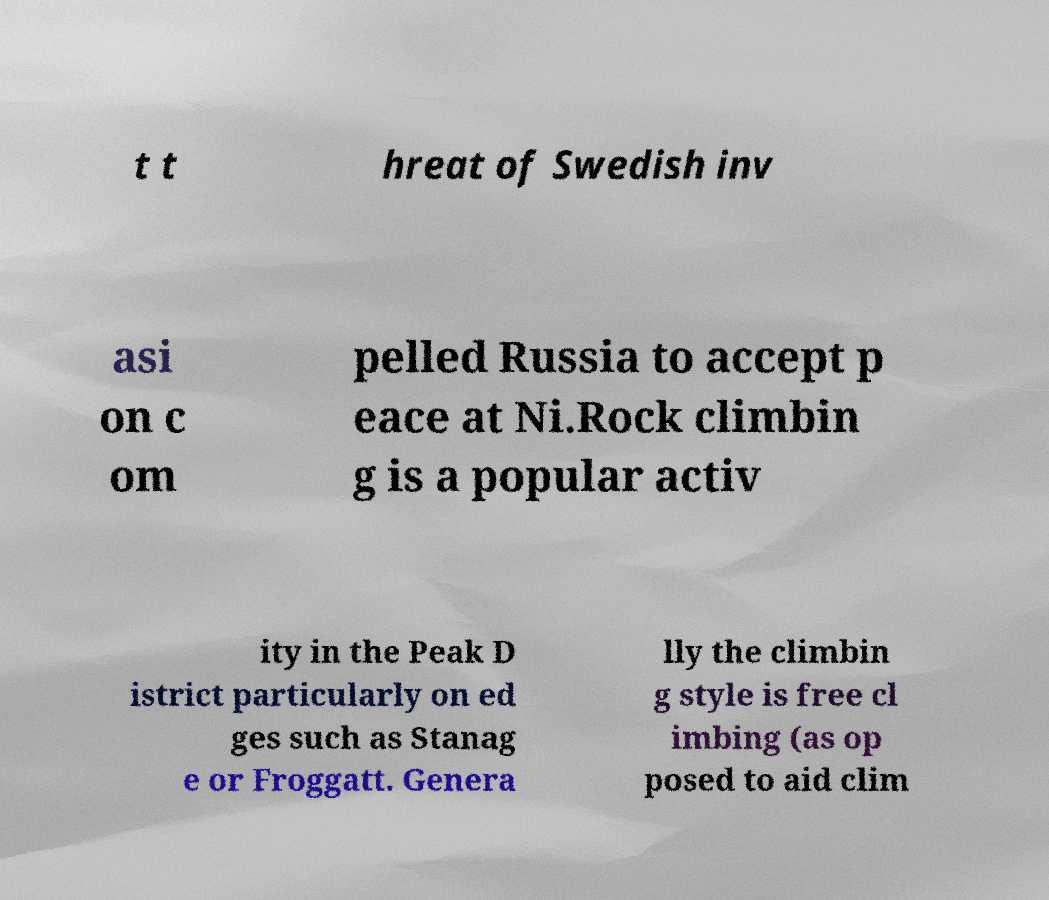For documentation purposes, I need the text within this image transcribed. Could you provide that? t t hreat of Swedish inv asi on c om pelled Russia to accept p eace at Ni.Rock climbin g is a popular activ ity in the Peak D istrict particularly on ed ges such as Stanag e or Froggatt. Genera lly the climbin g style is free cl imbing (as op posed to aid clim 